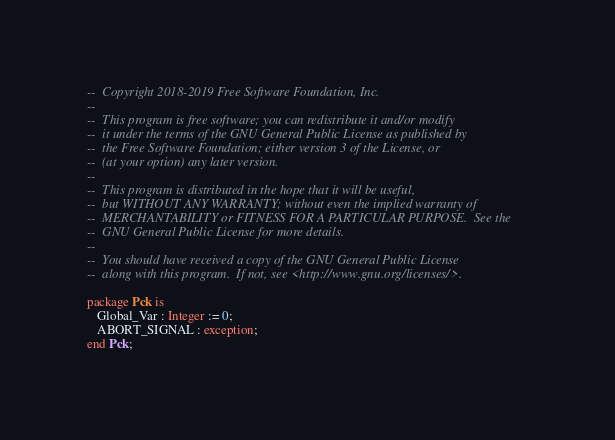Convert code to text. <code><loc_0><loc_0><loc_500><loc_500><_Ada_>--  Copyright 2018-2019 Free Software Foundation, Inc.
--
--  This program is free software; you can redistribute it and/or modify
--  it under the terms of the GNU General Public License as published by
--  the Free Software Foundation; either version 3 of the License, or
--  (at your option) any later version.
--
--  This program is distributed in the hope that it will be useful,
--  but WITHOUT ANY WARRANTY; without even the implied warranty of
--  MERCHANTABILITY or FITNESS FOR A PARTICULAR PURPOSE.  See the
--  GNU General Public License for more details.
--
--  You should have received a copy of the GNU General Public License
--  along with this program.  If not, see <http://www.gnu.org/licenses/>.

package Pck is
   Global_Var : Integer := 0;
   ABORT_SIGNAL : exception;
end Pck;
</code> 